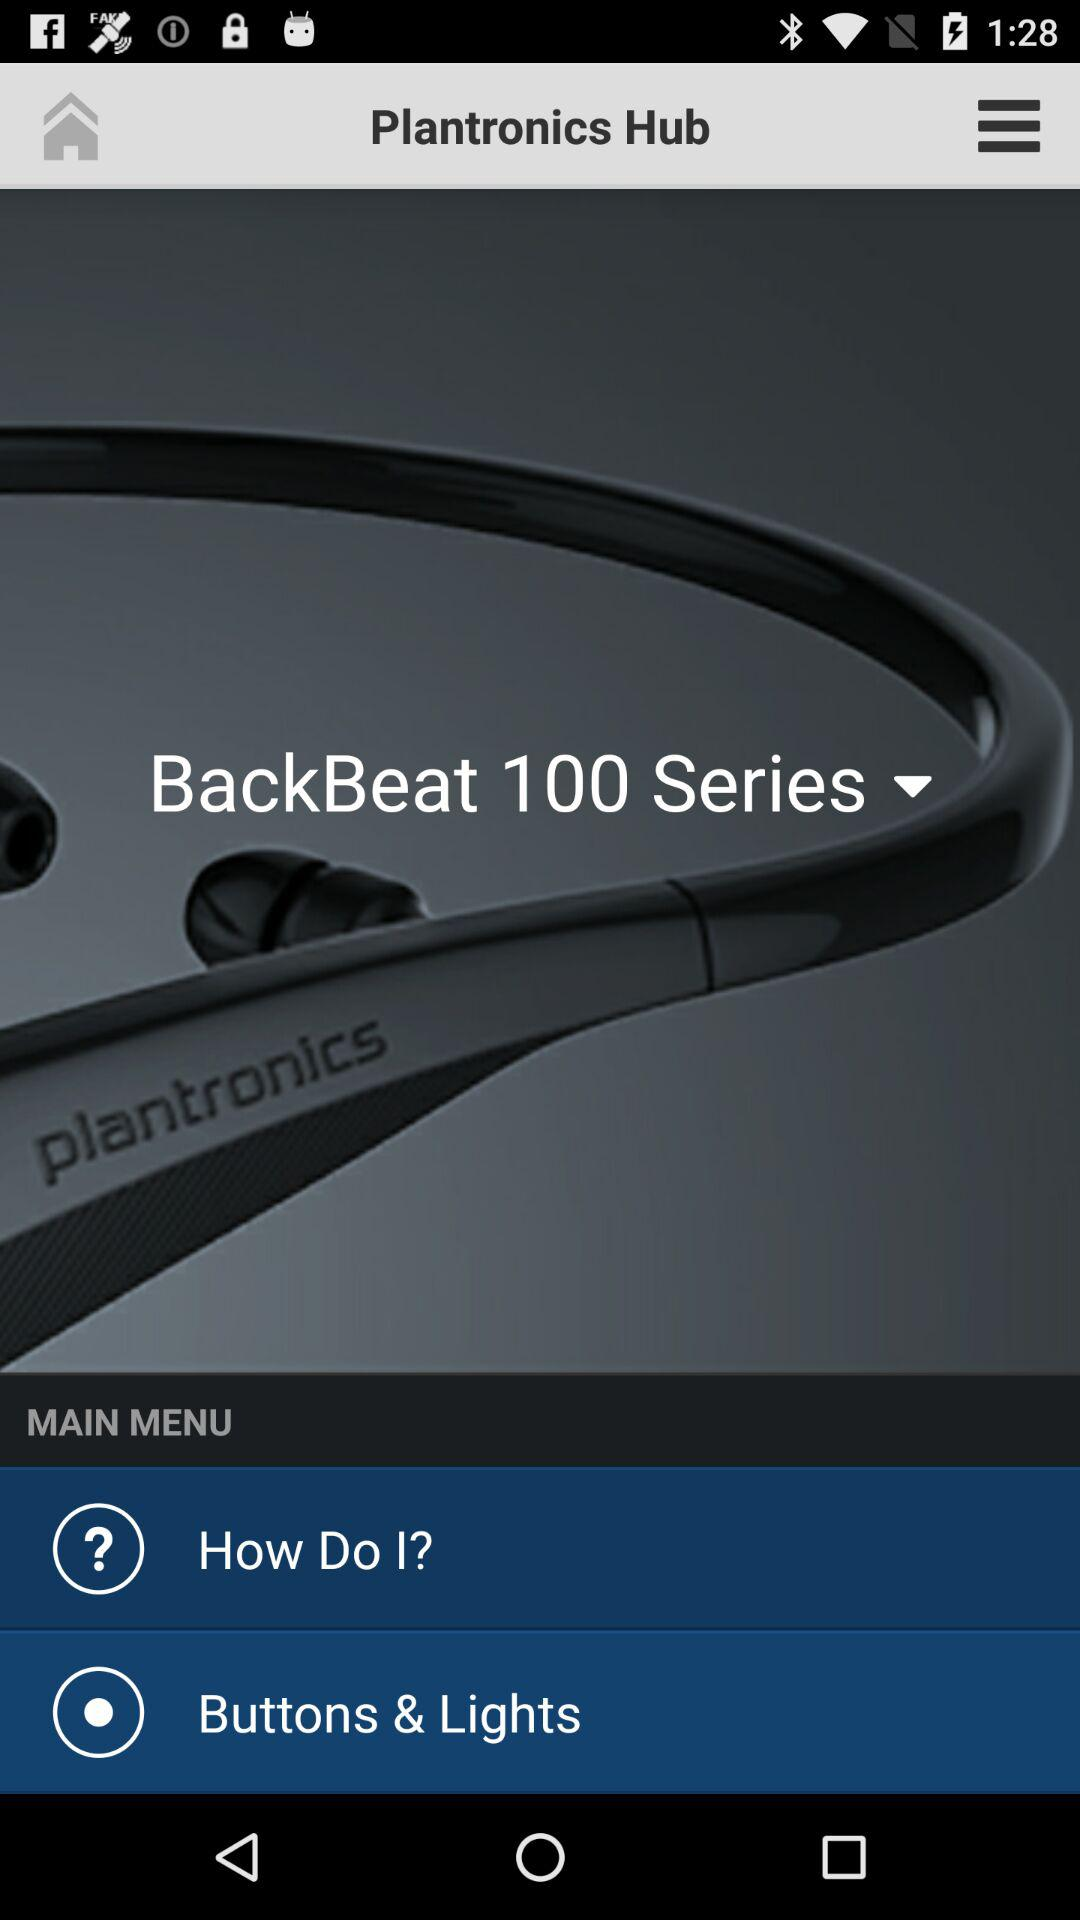How many items are in the main menu?
Answer the question using a single word or phrase. 2 